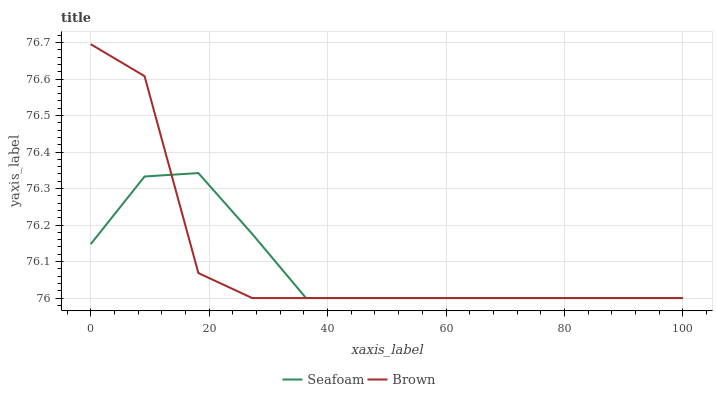Does Seafoam have the maximum area under the curve?
Answer yes or no. No. Is Seafoam the roughest?
Answer yes or no. No. Does Seafoam have the highest value?
Answer yes or no. No. 